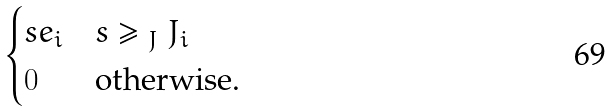Convert formula to latex. <formula><loc_0><loc_0><loc_500><loc_500>\begin{cases} s e _ { i } & s \geq _ { \ J } J _ { i } \\ 0 & \text {otherwise.} \end{cases}</formula> 